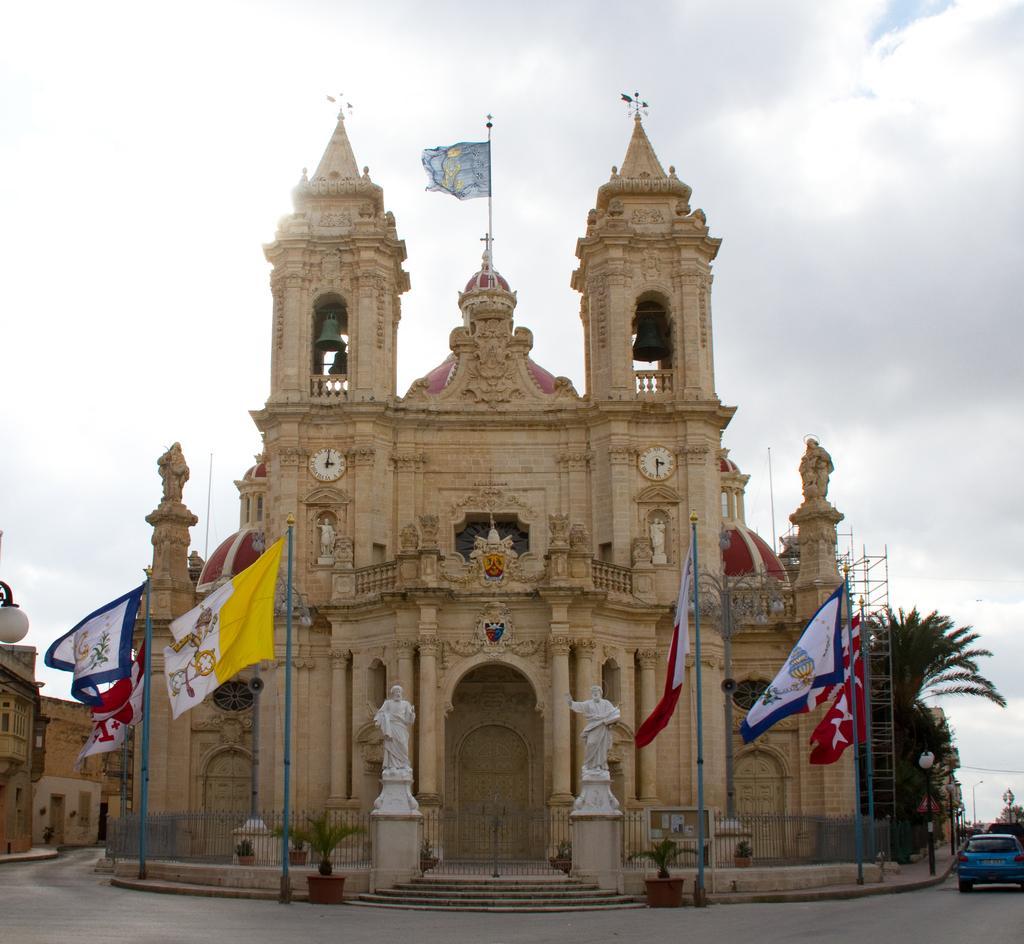Can you describe this image briefly? In this image I can see the road, few stairs, the metal railing, few vehicles on the road, few statues, few flags, few poles, few trees and a building. To the building I can see two clocks and a flag. In the background I can see few other buildings and the sky. 